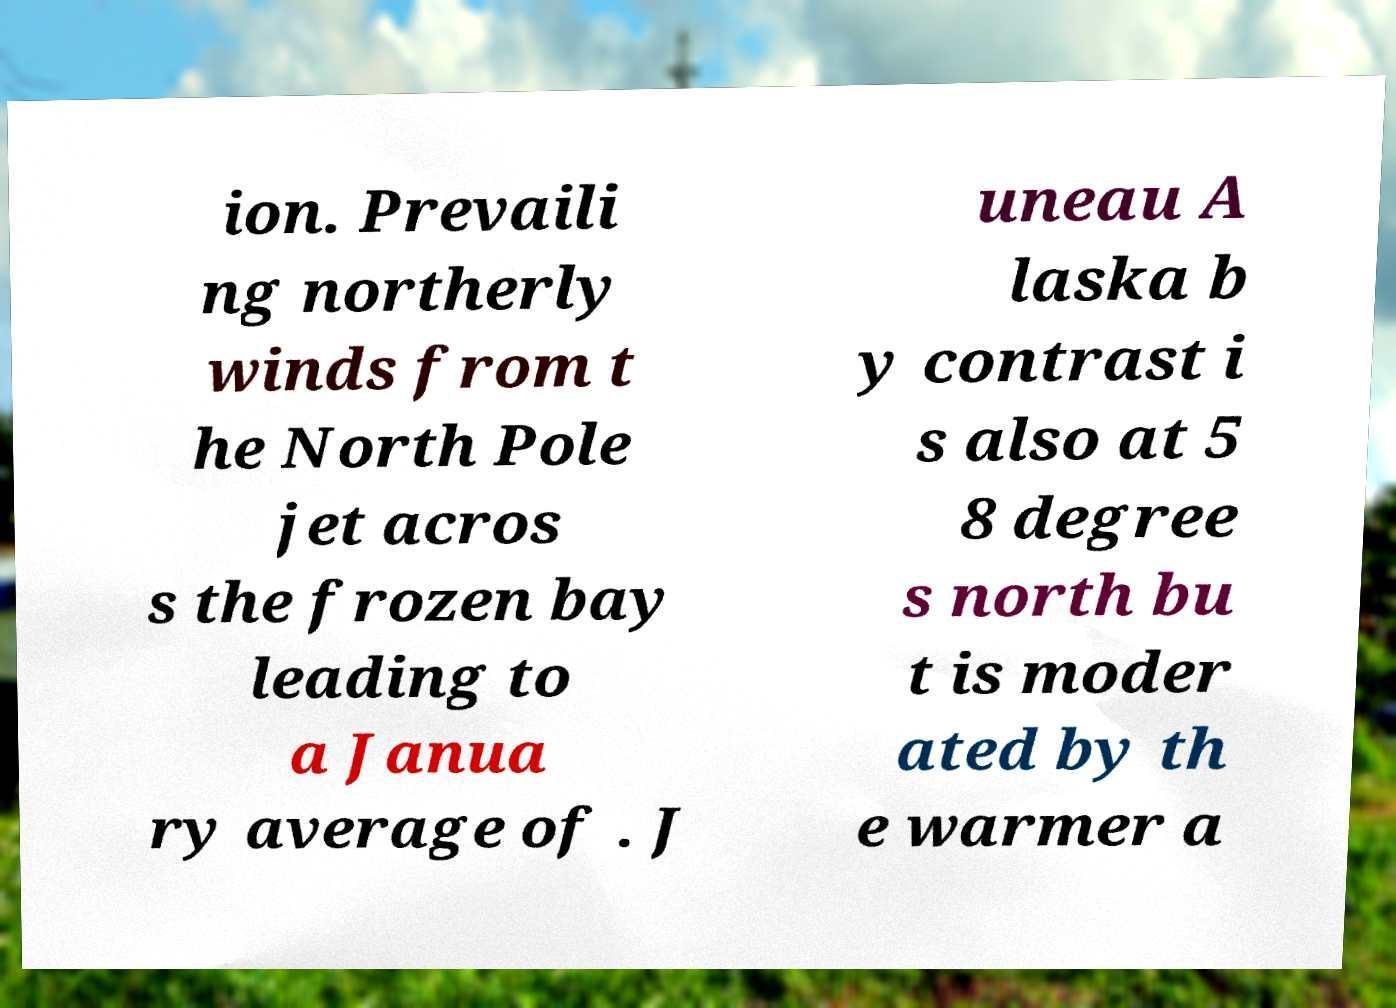For documentation purposes, I need the text within this image transcribed. Could you provide that? ion. Prevaili ng northerly winds from t he North Pole jet acros s the frozen bay leading to a Janua ry average of . J uneau A laska b y contrast i s also at 5 8 degree s north bu t is moder ated by th e warmer a 